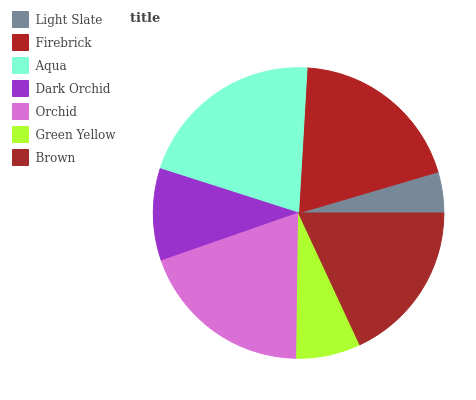Is Light Slate the minimum?
Answer yes or no. Yes. Is Aqua the maximum?
Answer yes or no. Yes. Is Firebrick the minimum?
Answer yes or no. No. Is Firebrick the maximum?
Answer yes or no. No. Is Firebrick greater than Light Slate?
Answer yes or no. Yes. Is Light Slate less than Firebrick?
Answer yes or no. Yes. Is Light Slate greater than Firebrick?
Answer yes or no. No. Is Firebrick less than Light Slate?
Answer yes or no. No. Is Brown the high median?
Answer yes or no. Yes. Is Brown the low median?
Answer yes or no. Yes. Is Dark Orchid the high median?
Answer yes or no. No. Is Green Yellow the low median?
Answer yes or no. No. 